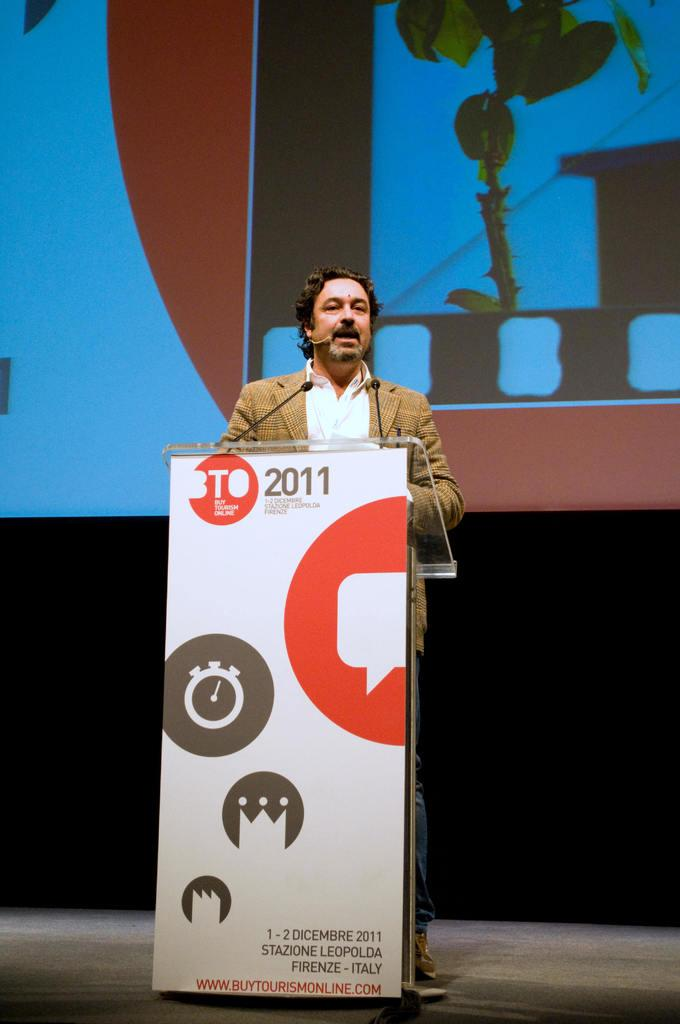<image>
Create a compact narrative representing the image presented. man giving speech at podium with BTO 2011 on it in Firenze, Italy 